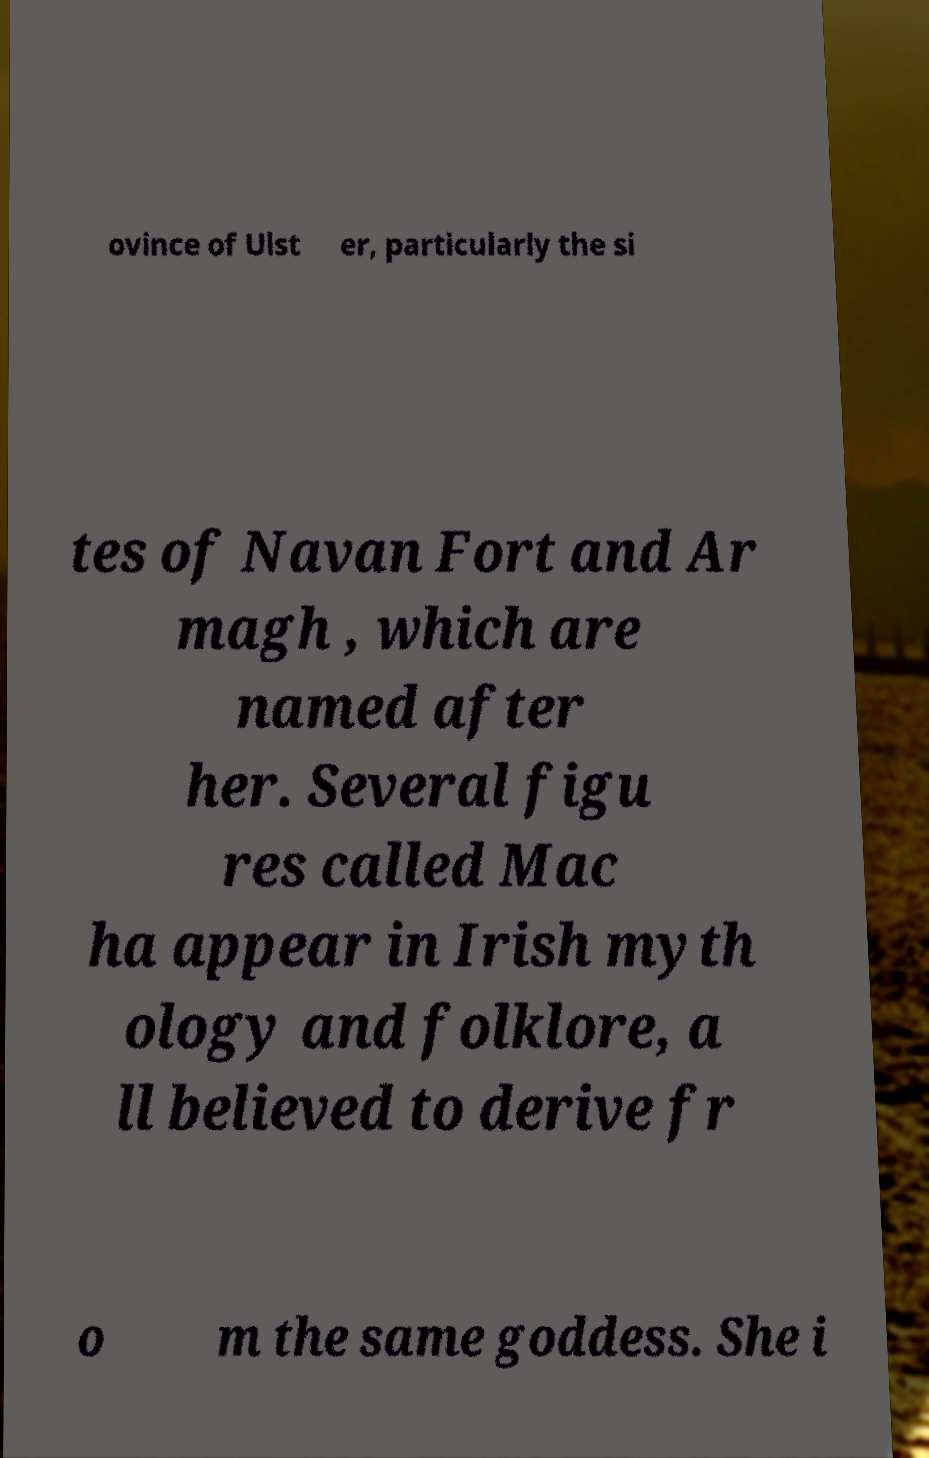Please read and relay the text visible in this image. What does it say? ovince of Ulst er, particularly the si tes of Navan Fort and Ar magh , which are named after her. Several figu res called Mac ha appear in Irish myth ology and folklore, a ll believed to derive fr o m the same goddess. She i 